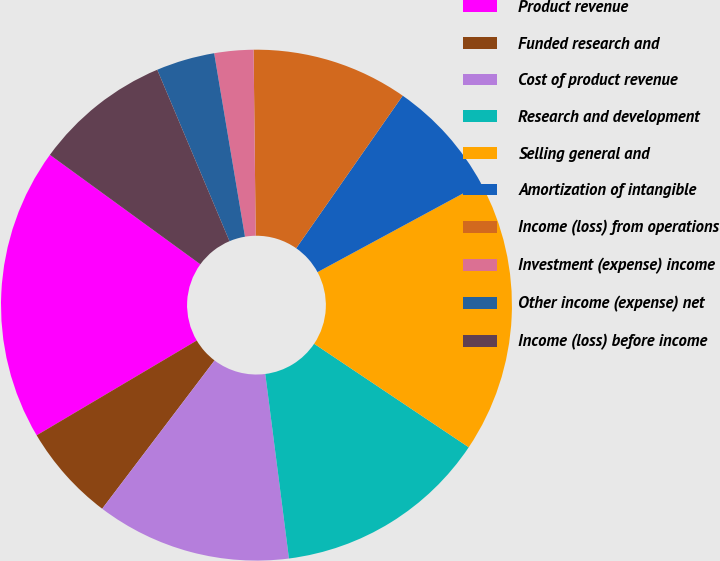Convert chart. <chart><loc_0><loc_0><loc_500><loc_500><pie_chart><fcel>Product revenue<fcel>Funded research and<fcel>Cost of product revenue<fcel>Research and development<fcel>Selling general and<fcel>Amortization of intangible<fcel>Income (loss) from operations<fcel>Investment (expense) income<fcel>Other income (expense) net<fcel>Income (loss) before income<nl><fcel>18.52%<fcel>6.17%<fcel>12.35%<fcel>13.58%<fcel>17.28%<fcel>7.41%<fcel>9.88%<fcel>2.47%<fcel>3.7%<fcel>8.64%<nl></chart> 